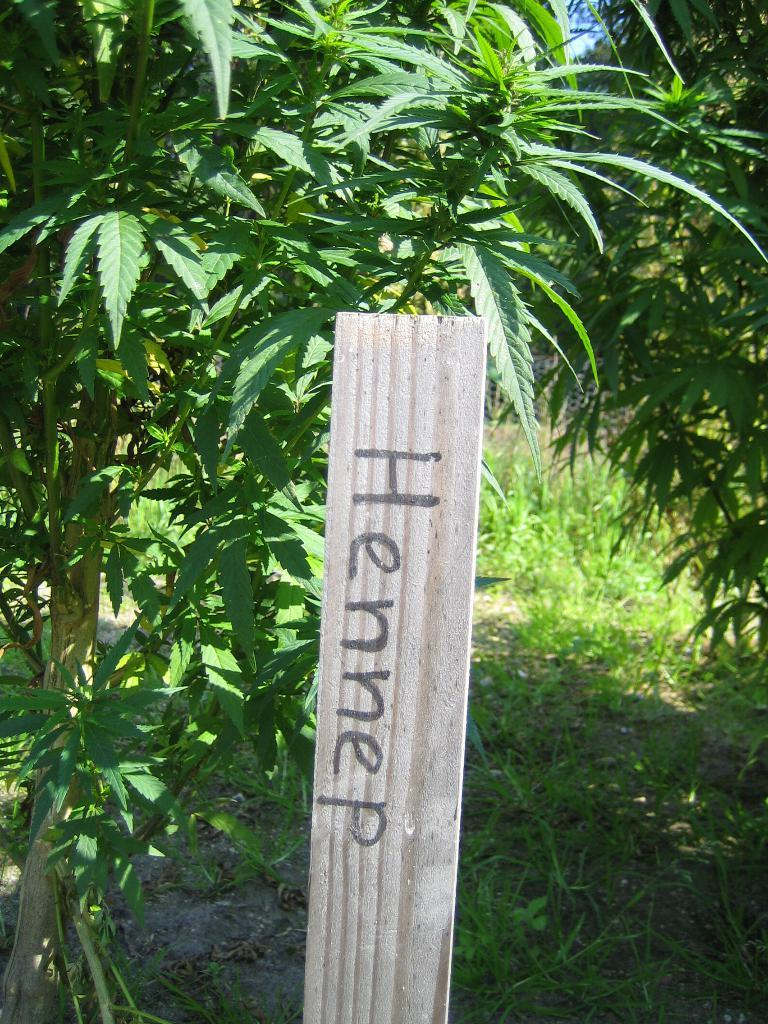What is written on the pole or board in the image? The text "HENNEP" is written on the pole or board in the image. What type of vegetation is visible at the bottom of the image? Grass is visible at the bottom of the image. What can be seen in the background of the image? There are trees in the background of the image. Where is the nest of the bird in the image? There is no bird or nest present in the image. What type of salt is used to season the grass in the image? The grass in the image does not require salt for seasoning, as it is a natural element. 